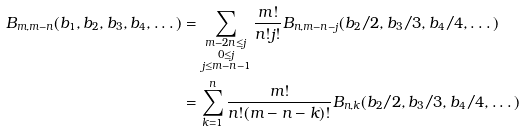Convert formula to latex. <formula><loc_0><loc_0><loc_500><loc_500>B _ { m , m - n } ( b _ { 1 } , b _ { 2 } , b _ { 3 } , b _ { 4 } , \dots ) & = \sum _ { \substack { m - 2 n \leq j \\ 0 \leq j \\ j \leq m - n - 1 } } \frac { m ! } { n ! j ! } B _ { n , m - n - j } ( b _ { 2 } / 2 , b _ { 3 } / 3 , b _ { 4 } / 4 , \dots ) \\ & = \sum _ { k = 1 } ^ { n } \frac { m ! } { n ! ( m - n - k ) ! } B _ { n , k } ( b _ { 2 } / 2 , b _ { 3 } / 3 , b _ { 4 } / 4 , \dots )</formula> 